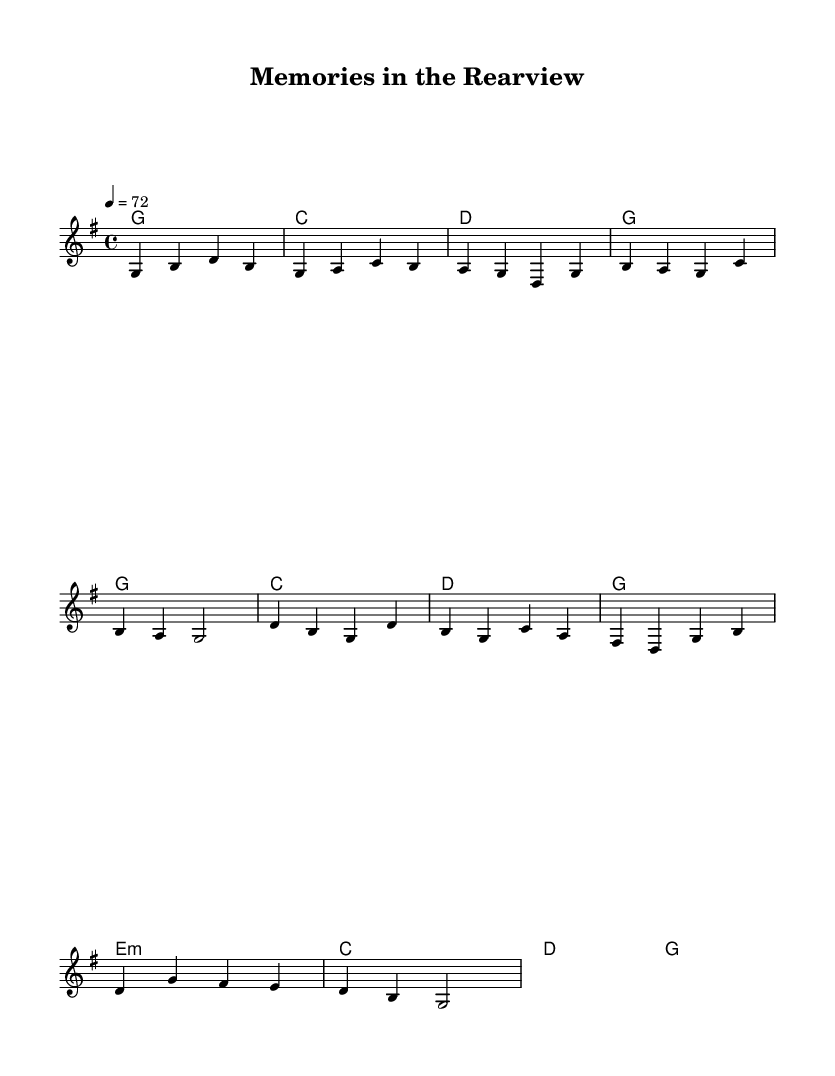What is the key signature of this music? The key signature is G major, which has one sharp (F#). This can be identified in the global section of the code where it states "\key g \major".
Answer: G major What is the time signature of this music? The time signature is 4/4, as indicated in the global section of the code with "\time 4/4". This means each measure has four beats, and each quarter note receives one beat.
Answer: 4/4 What is the tempo of this song? The tempo is 72 beats per minute, which can be found in the global section specifying "4 = 72". This indicates the speed of the music.
Answer: 72 What is the chord progression for the verse section? The chord progression for the verse section is G, C, D, G. This can be inferred from the chordmode section showing the sequence of chords aligned with the melody line structure.
Answer: G, C, D, G How many measures are in the chorus? There are 8 measures in the chorus. By examining the harmony section, we can see there are 8 distinct chords in the chorus section, each representing a measure.
Answer: 8 Which chord is predominantly used in the chorus? The G major chord is predominantly used in the chorus, appearing at the beginning and end, suggesting it is the tonic chord. This is indicated by its repetition in the chord progression.
Answer: G What is the rhythmic value of the first note in the melody? The first note in the melody is a quarter note, shown as "g4" in the melody section, where "4" signifies a quarter note duration.
Answer: quarter note 